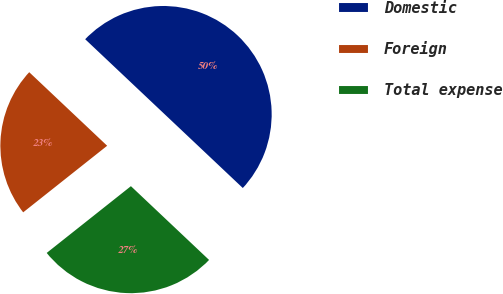<chart> <loc_0><loc_0><loc_500><loc_500><pie_chart><fcel>Domestic<fcel>Foreign<fcel>Total expense<nl><fcel>50.0%<fcel>22.71%<fcel>27.29%<nl></chart> 